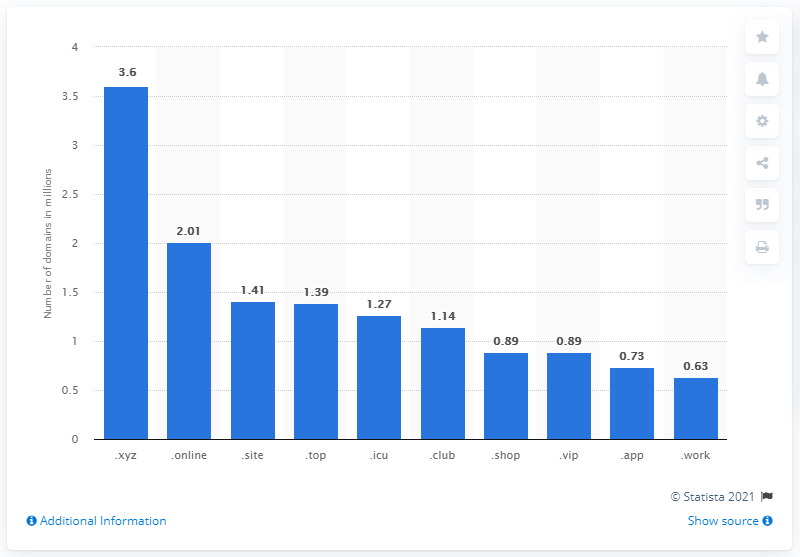Indicate a few pertinent items in this graphic. As of April 2021, there were approximately 3.6 million .xyz domain names in existence. 